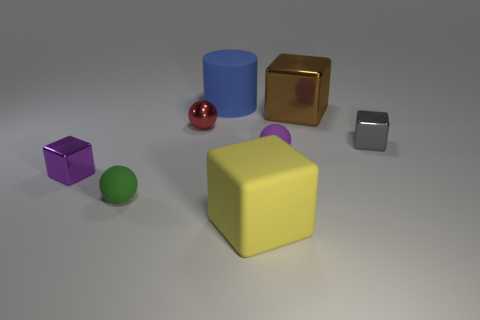The brown block has what size?
Give a very brief answer. Large. What number of other things are the same shape as the large yellow rubber thing?
Offer a very short reply. 3. Are there an equal number of tiny green balls on the right side of the purple sphere and tiny gray metallic cubes in front of the brown metallic object?
Give a very brief answer. No. What is the material of the tiny purple ball?
Your answer should be very brief. Rubber. There is a purple object that is on the right side of the rubber cylinder; what is it made of?
Keep it short and to the point. Rubber. Is the number of tiny rubber spheres on the left side of the yellow matte block greater than the number of tiny purple matte cubes?
Keep it short and to the point. Yes. Is there a small shiny block that is behind the small rubber thing that is right of the large object that is in front of the purple matte object?
Offer a very short reply. Yes. There is a purple matte sphere; are there any small metallic cubes in front of it?
Provide a short and direct response. Yes. The brown thing that is the same material as the red thing is what size?
Ensure brevity in your answer.  Large. There is a matte block in front of the gray object that is behind the tiny rubber ball that is left of the small red thing; how big is it?
Make the answer very short. Large. 